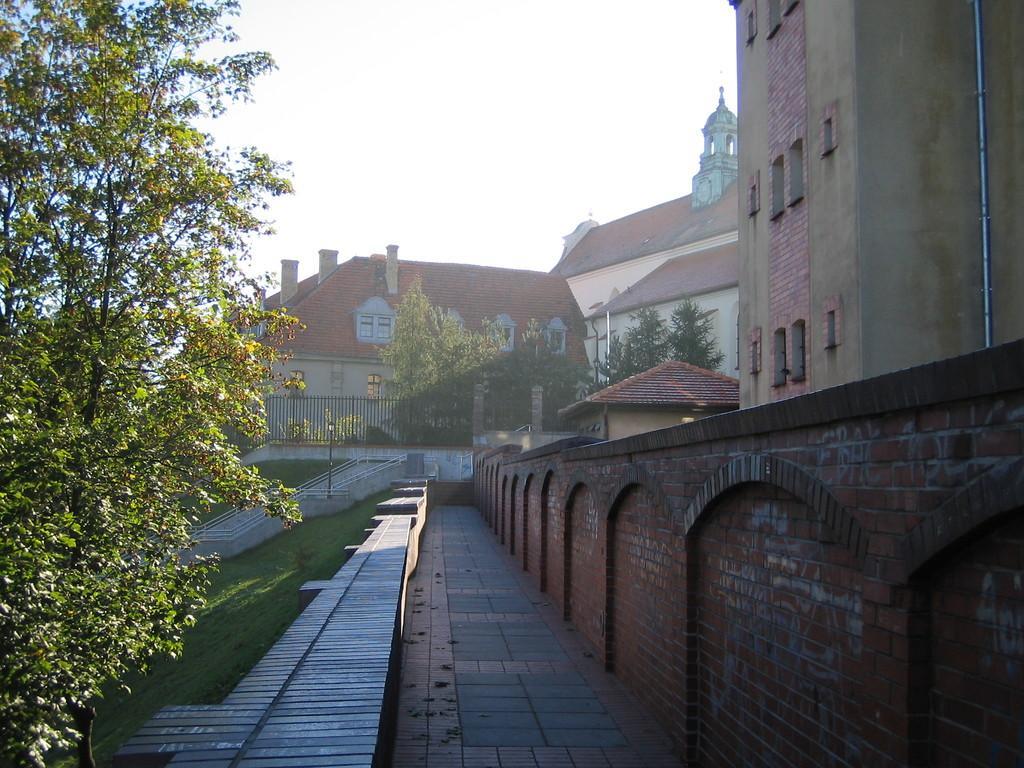How would you summarize this image in a sentence or two? In this picture we can see the buildings and monument. in the center we can see the streetlights and black fencing. On the left we can see the trees and grass. At the top there is a sky. 